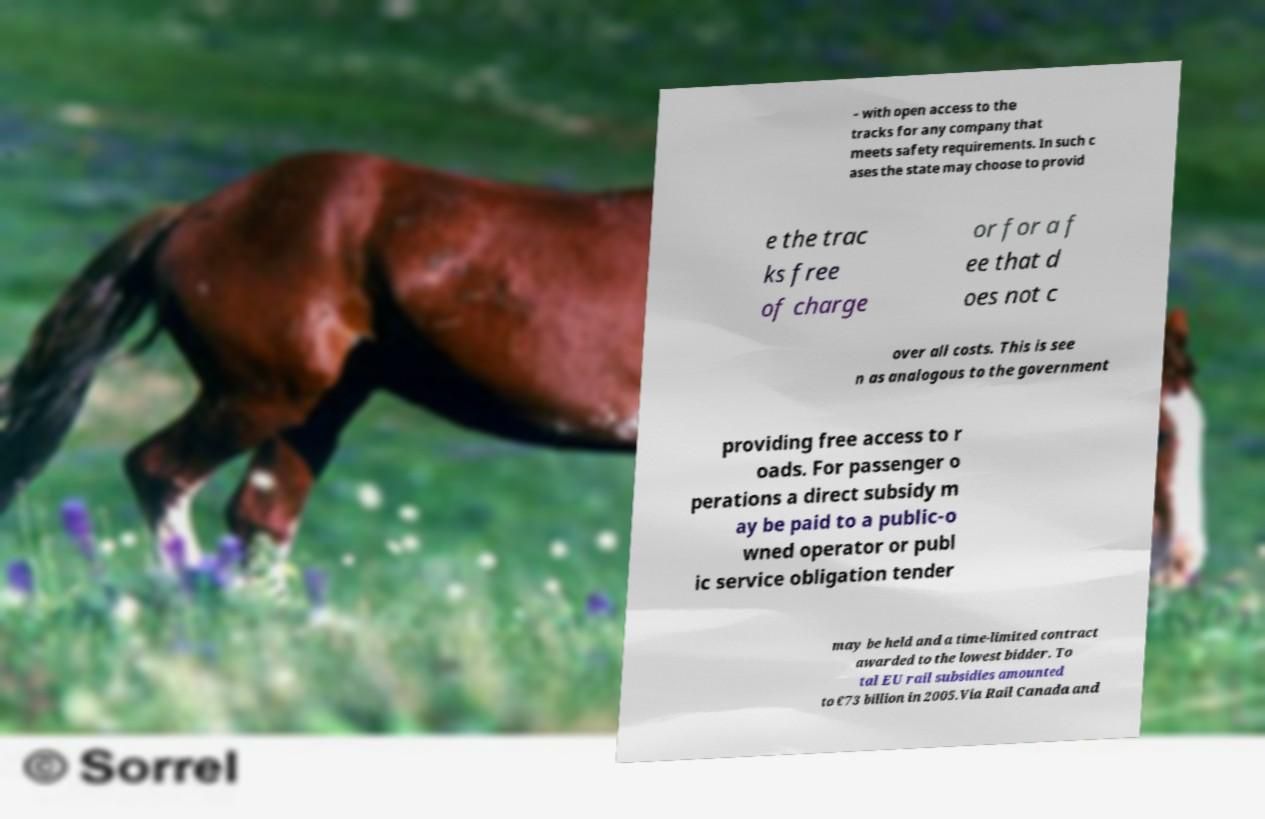Please read and relay the text visible in this image. What does it say? – with open access to the tracks for any company that meets safety requirements. In such c ases the state may choose to provid e the trac ks free of charge or for a f ee that d oes not c over all costs. This is see n as analogous to the government providing free access to r oads. For passenger o perations a direct subsidy m ay be paid to a public-o wned operator or publ ic service obligation tender may be held and a time-limited contract awarded to the lowest bidder. To tal EU rail subsidies amounted to €73 billion in 2005.Via Rail Canada and 